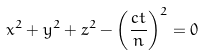Convert formula to latex. <formula><loc_0><loc_0><loc_500><loc_500>x ^ { 2 } + y ^ { 2 } + z ^ { 2 } - \left ( \frac { c t } { n } \right ) ^ { 2 } = 0</formula> 